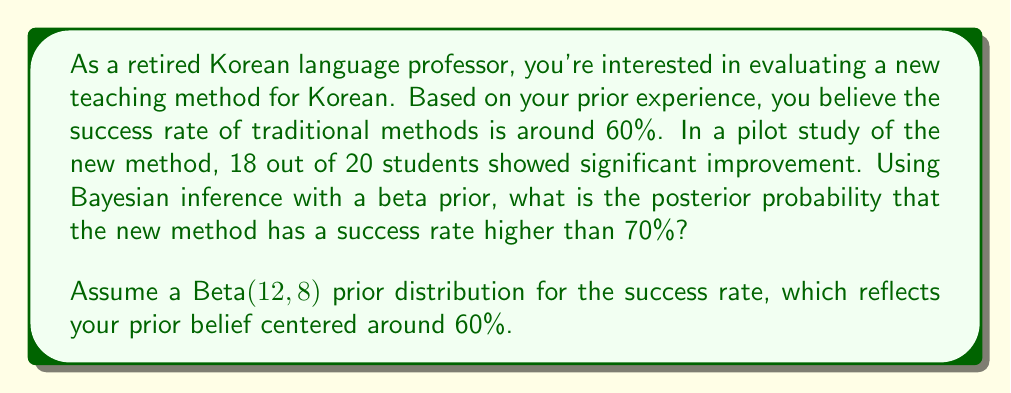Provide a solution to this math problem. Let's approach this step-by-step using Bayesian inference:

1) We start with a Beta(12, 8) prior, which has a mean of 12 / (12 + 8) = 0.6, reflecting our prior belief of a 60% success rate.

2) The likelihood from our data is Binomial(20, θ), where we observed 18 successes out of 20 trials.

3) The posterior distribution is Beta(α + successes, β + failures), where α and β are the parameters of our prior Beta distribution. So our posterior is Beta(12 + 18, 8 + 2) = Beta(30, 10).

4) We want to find P(θ > 0.7 | data), where θ is the success rate.

5) For a Beta(a, b) distribution, the probability that the random variable is greater than some value x is given by the regularized incomplete beta function:

   $$P(X > x) = 1 - I_x(a, b)$$

   where $I_x(a, b)$ is the regularized incomplete beta function.

6) In our case, we need to calculate:

   $$P(\theta > 0.7 | data) = 1 - I_{0.7}(30, 10)$$

7) This can be computed using statistical software or numerical integration. Using such methods, we find:

   $$1 - I_{0.7}(30, 10) \approx 0.9948$$

Therefore, based on our prior beliefs and the observed data, there is approximately a 99.48% probability that the new method has a success rate higher than 70%.
Answer: The posterior probability that the new Korean language teaching method has a success rate higher than 70% is approximately 0.9948 or 99.48%. 